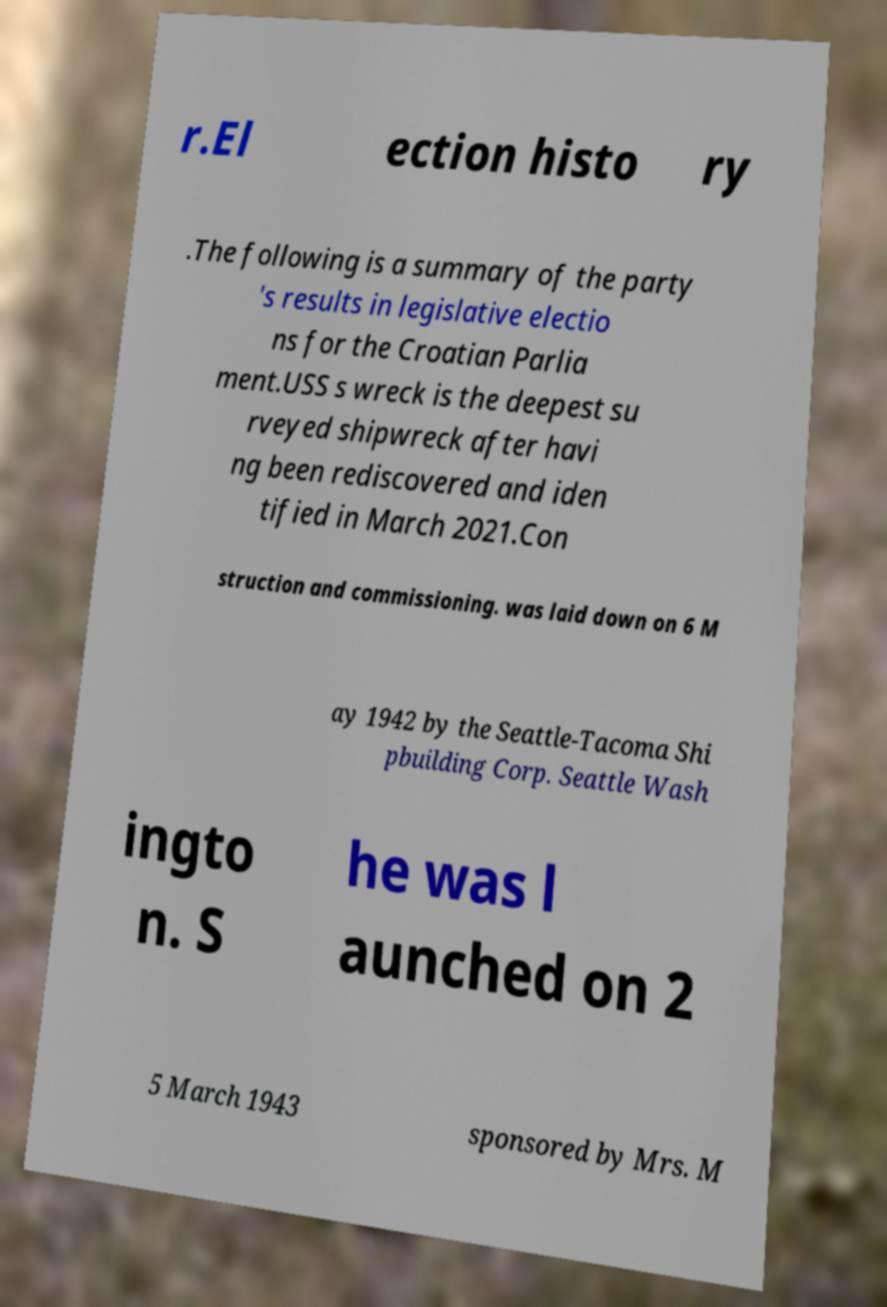Can you accurately transcribe the text from the provided image for me? r.El ection histo ry .The following is a summary of the party 's results in legislative electio ns for the Croatian Parlia ment.USS s wreck is the deepest su rveyed shipwreck after havi ng been rediscovered and iden tified in March 2021.Con struction and commissioning. was laid down on 6 M ay 1942 by the Seattle-Tacoma Shi pbuilding Corp. Seattle Wash ingto n. S he was l aunched on 2 5 March 1943 sponsored by Mrs. M 